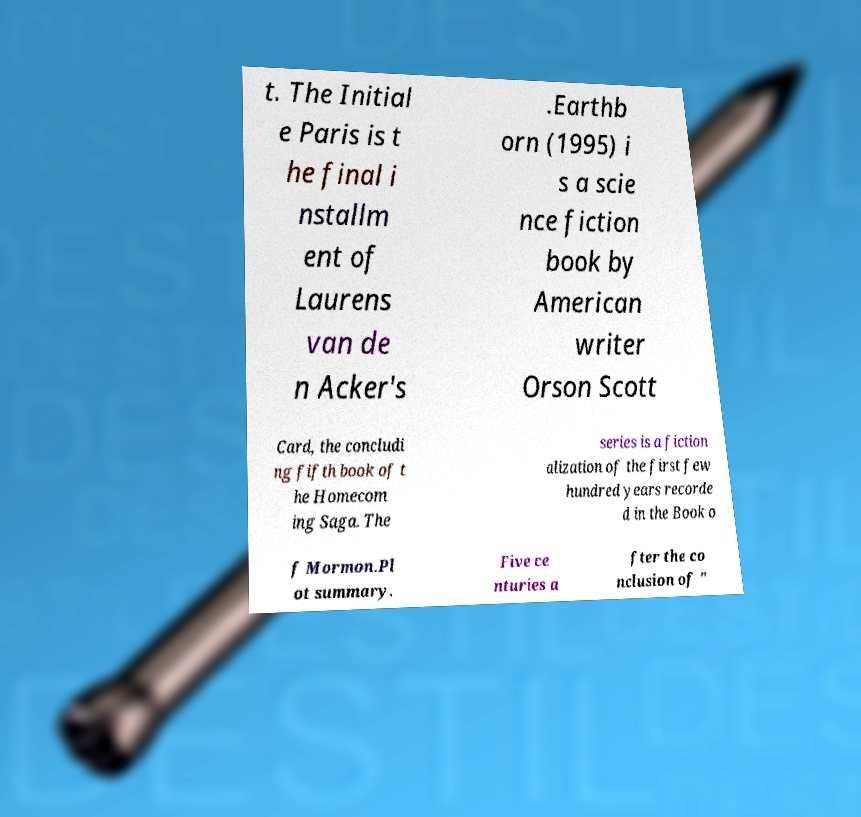Please identify and transcribe the text found in this image. t. The Initial e Paris is t he final i nstallm ent of Laurens van de n Acker's .Earthb orn (1995) i s a scie nce fiction book by American writer Orson Scott Card, the concludi ng fifth book of t he Homecom ing Saga. The series is a fiction alization of the first few hundred years recorde d in the Book o f Mormon.Pl ot summary. Five ce nturies a fter the co nclusion of " 